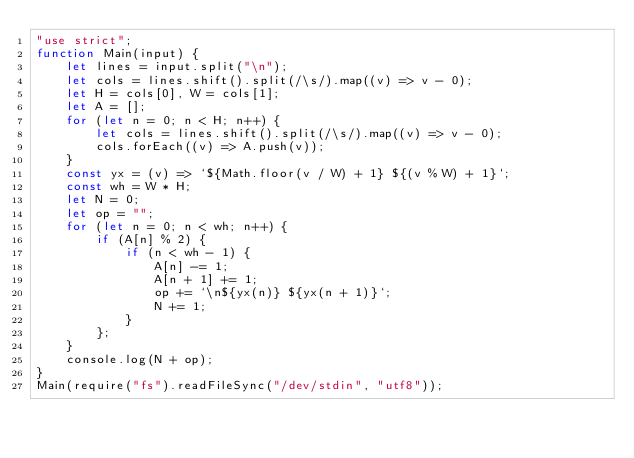<code> <loc_0><loc_0><loc_500><loc_500><_JavaScript_>"use strict";
function Main(input) {
    let lines = input.split("\n");
    let cols = lines.shift().split(/\s/).map((v) => v - 0);
    let H = cols[0], W = cols[1];
    let A = [];
    for (let n = 0; n < H; n++) {
        let cols = lines.shift().split(/\s/).map((v) => v - 0);
        cols.forEach((v) => A.push(v));
    }
    const yx = (v) => `${Math.floor(v / W) + 1} ${(v % W) + 1}`;
    const wh = W * H;
    let N = 0;
    let op = "";
    for (let n = 0; n < wh; n++) {
        if (A[n] % 2) {
            if (n < wh - 1) {
                A[n] -= 1;
                A[n + 1] += 1;
                op += `\n${yx(n)} ${yx(n + 1)}`;
                N += 1;
            }
        };
    }
    console.log(N + op);
}
Main(require("fs").readFileSync("/dev/stdin", "utf8"));
</code> 